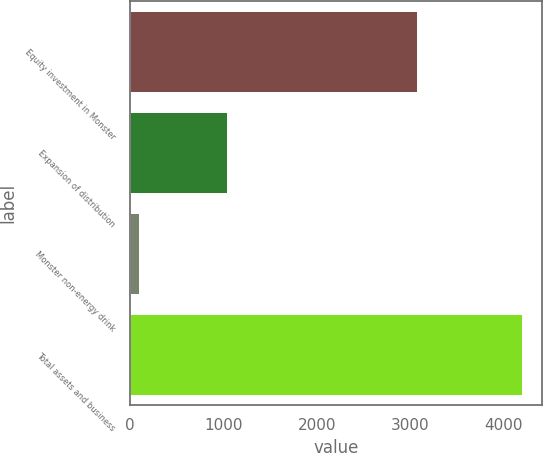<chart> <loc_0><loc_0><loc_500><loc_500><bar_chart><fcel>Equity investment in Monster<fcel>Expansion of distribution<fcel>Monster non-energy drink<fcel>Total assets and business<nl><fcel>3066<fcel>1035<fcel>95<fcel>4196<nl></chart> 